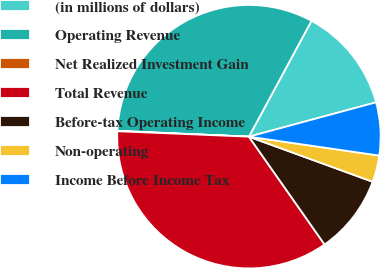Convert chart. <chart><loc_0><loc_0><loc_500><loc_500><pie_chart><fcel>(in millions of dollars)<fcel>Operating Revenue<fcel>Net Realized Investment Gain<fcel>Total Revenue<fcel>Before-tax Operating Income<fcel>Non-operating<fcel>Income Before Income Tax<nl><fcel>12.92%<fcel>32.18%<fcel>0.05%<fcel>35.4%<fcel>9.7%<fcel>3.27%<fcel>6.49%<nl></chart> 